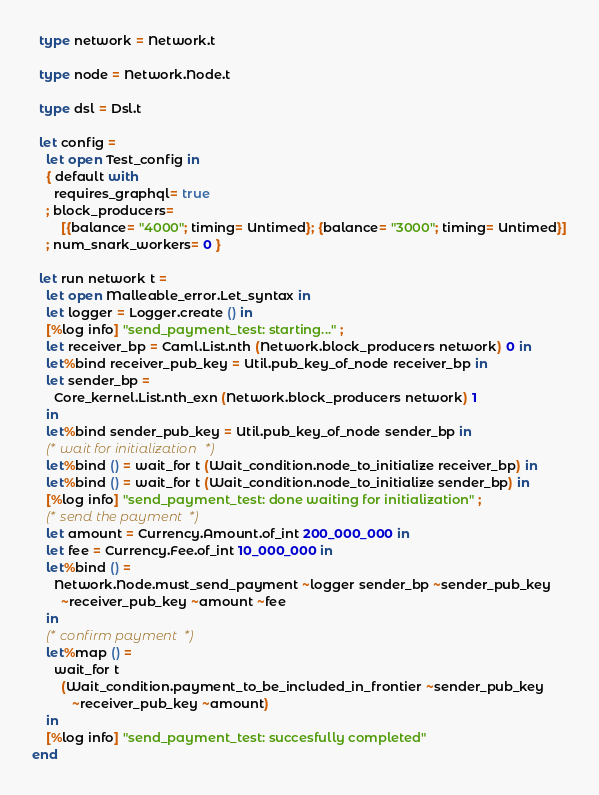Convert code to text. <code><loc_0><loc_0><loc_500><loc_500><_OCaml_>  type network = Network.t

  type node = Network.Node.t

  type dsl = Dsl.t

  let config =
    let open Test_config in
    { default with
      requires_graphql= true
    ; block_producers=
        [{balance= "4000"; timing= Untimed}; {balance= "3000"; timing= Untimed}]
    ; num_snark_workers= 0 }

  let run network t =
    let open Malleable_error.Let_syntax in
    let logger = Logger.create () in
    [%log info] "send_payment_test: starting..." ;
    let receiver_bp = Caml.List.nth (Network.block_producers network) 0 in
    let%bind receiver_pub_key = Util.pub_key_of_node receiver_bp in
    let sender_bp =
      Core_kernel.List.nth_exn (Network.block_producers network) 1
    in
    let%bind sender_pub_key = Util.pub_key_of_node sender_bp in
    (* wait for initialization *)
    let%bind () = wait_for t (Wait_condition.node_to_initialize receiver_bp) in
    let%bind () = wait_for t (Wait_condition.node_to_initialize sender_bp) in
    [%log info] "send_payment_test: done waiting for initialization" ;
    (* send the payment *)
    let amount = Currency.Amount.of_int 200_000_000 in
    let fee = Currency.Fee.of_int 10_000_000 in
    let%bind () =
      Network.Node.must_send_payment ~logger sender_bp ~sender_pub_key
        ~receiver_pub_key ~amount ~fee
    in
    (* confirm payment *)
    let%map () =
      wait_for t
        (Wait_condition.payment_to_be_included_in_frontier ~sender_pub_key
           ~receiver_pub_key ~amount)
    in
    [%log info] "send_payment_test: succesfully completed"
end
</code> 